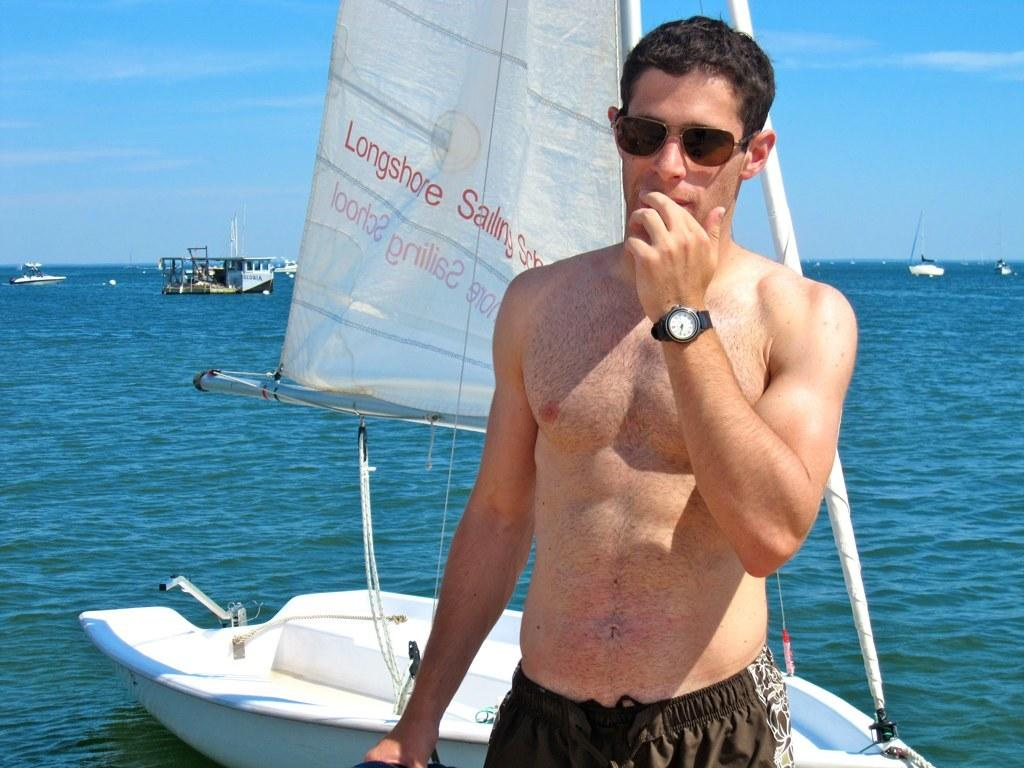What is the main subject of the image? There is a man standing in the image. What accessories is the man wearing? The man is wearing shades and a watch. What can be seen in the background of the image? There are boats, water, and the sky visible in the background of the image. Is there a woman in the image with a cast on her leg? There is no woman or cast present in the image; it features a man standing with shades and a watch. 